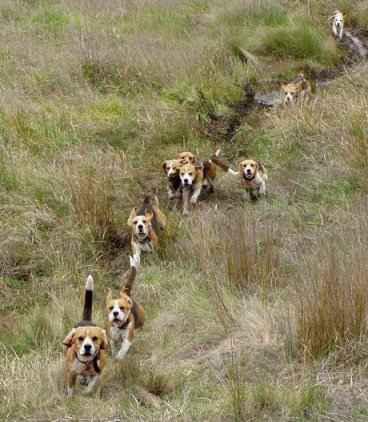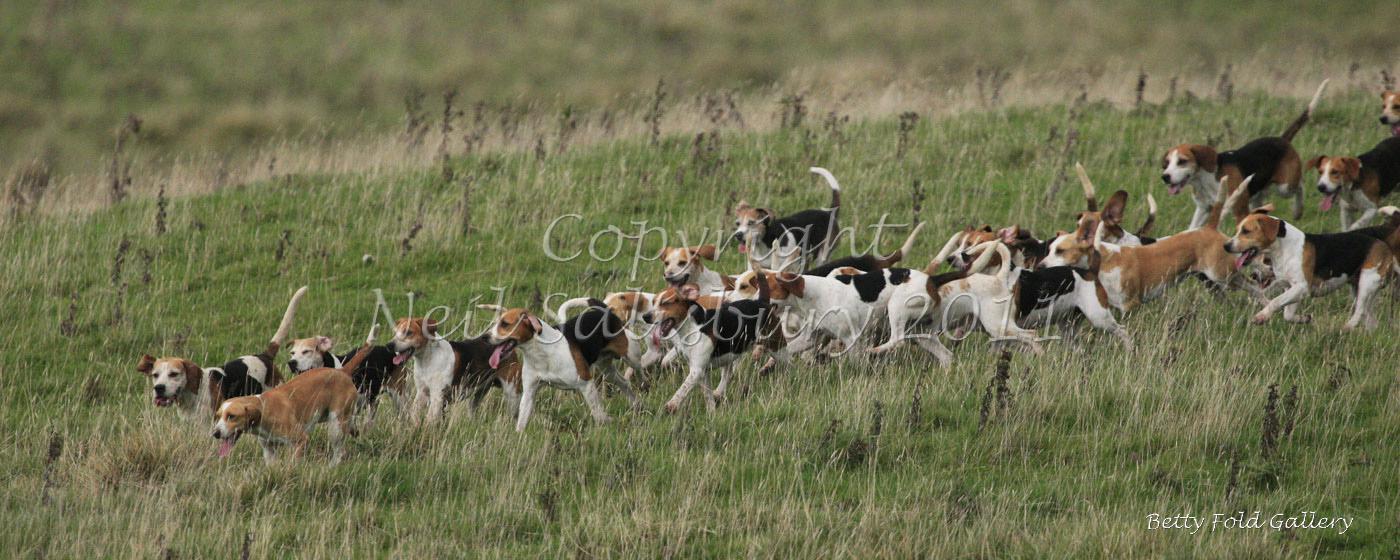The first image is the image on the left, the second image is the image on the right. Given the left and right images, does the statement "There is a person standing among several dogs in the image on the right." hold true? Answer yes or no. No. The first image is the image on the left, the second image is the image on the right. For the images displayed, is the sentence "Both photos show dogs running in the grass." factually correct? Answer yes or no. Yes. The first image is the image on the left, the second image is the image on the right. Examine the images to the left and right. Is the description "There is one person standing in the image on the right." accurate? Answer yes or no. No. 